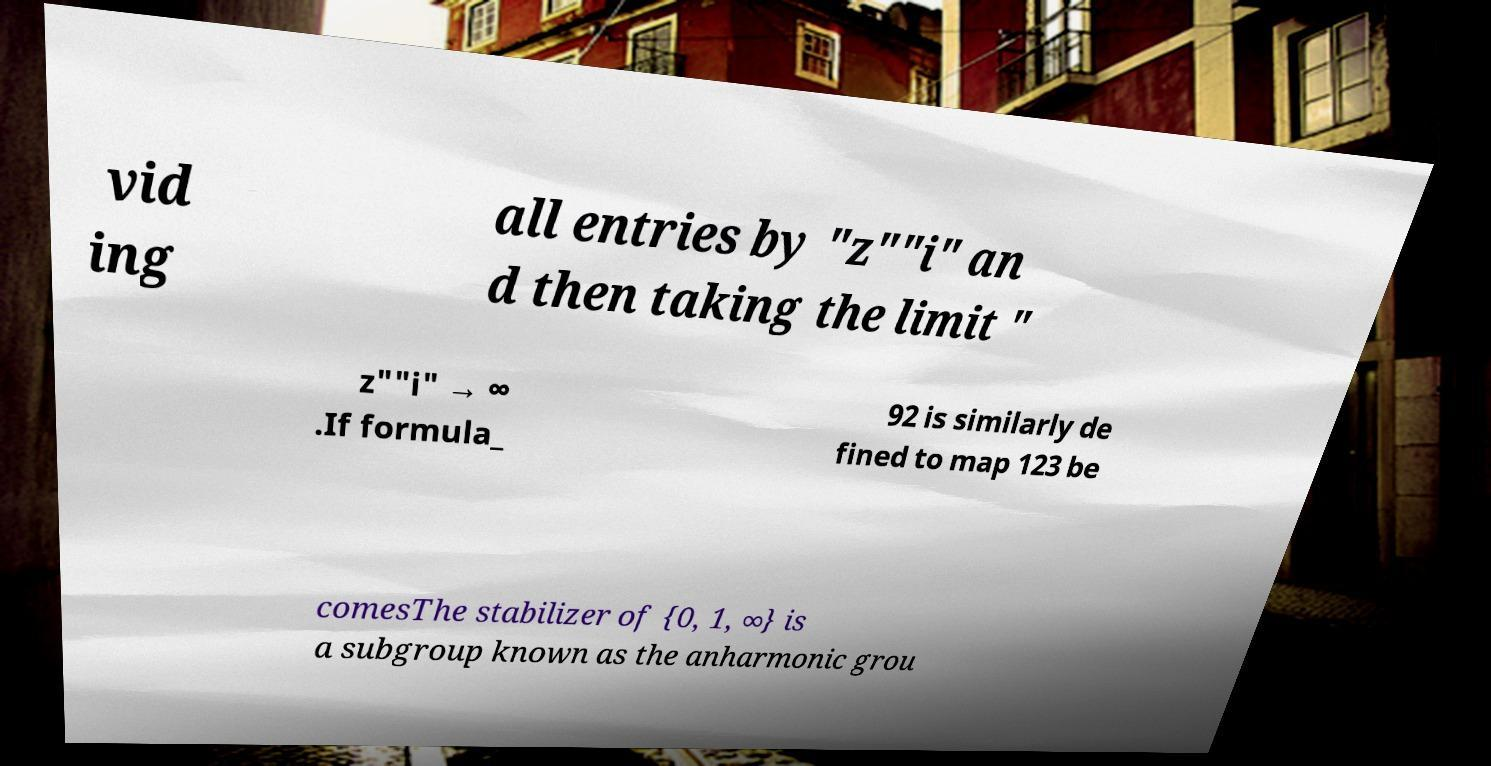There's text embedded in this image that I need extracted. Can you transcribe it verbatim? vid ing all entries by "z""i" an d then taking the limit " z""i" → ∞ .If formula_ 92 is similarly de fined to map 123 be comesThe stabilizer of {0, 1, ∞} is a subgroup known as the anharmonic grou 